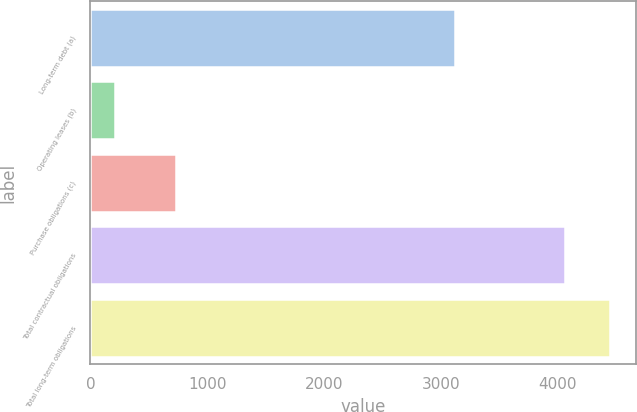Convert chart. <chart><loc_0><loc_0><loc_500><loc_500><bar_chart><fcel>Long-term debt (a)<fcel>Operating leases (b)<fcel>Purchase obligations (c)<fcel>Total contractual obligations<fcel>Total long-term obligations<nl><fcel>3122.6<fcel>208<fcel>728.8<fcel>4059.6<fcel>4444.76<nl></chart> 